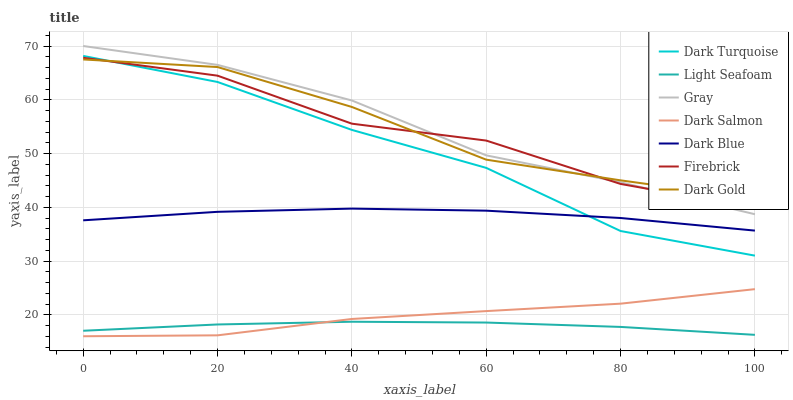Does Dark Gold have the minimum area under the curve?
Answer yes or no. No. Does Dark Gold have the maximum area under the curve?
Answer yes or no. No. Is Dark Gold the smoothest?
Answer yes or no. No. Is Dark Gold the roughest?
Answer yes or no. No. Does Dark Turquoise have the lowest value?
Answer yes or no. No. Does Dark Gold have the highest value?
Answer yes or no. No. Is Dark Salmon less than Firebrick?
Answer yes or no. Yes. Is Gray greater than Dark Blue?
Answer yes or no. Yes. Does Dark Salmon intersect Firebrick?
Answer yes or no. No. 